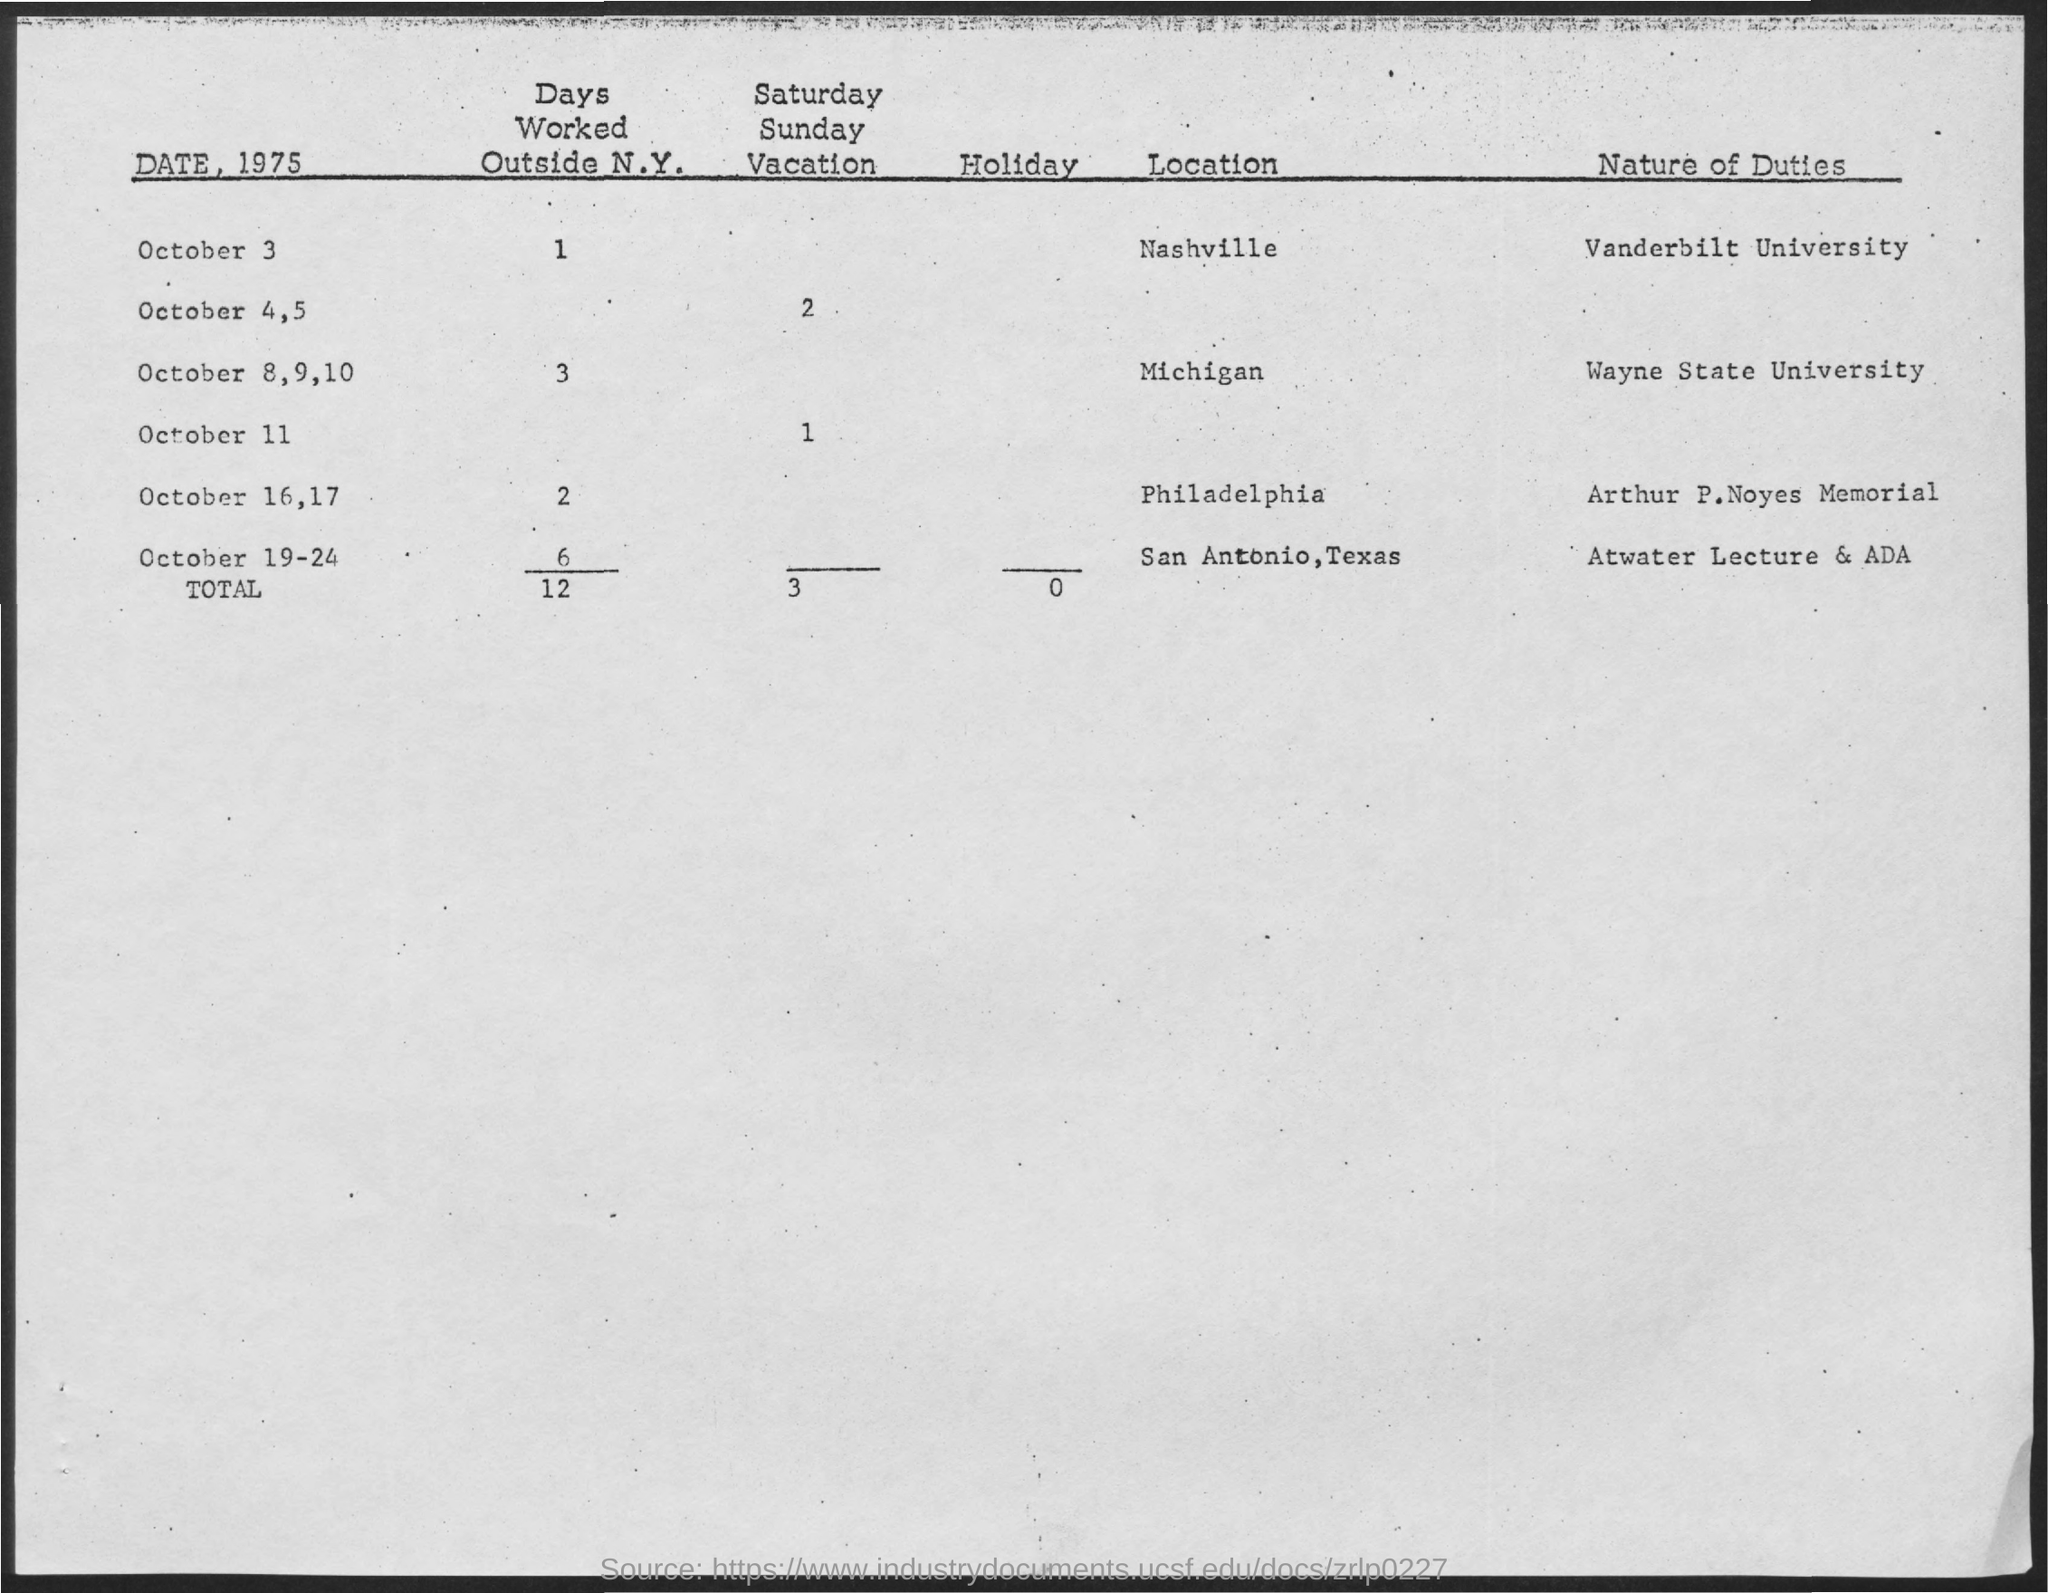List a handful of essential elements in this visual. In total, the individual worked 12 days outside of New York. On October 3, the number of days worked outside of New York is one. What is the nature of duty on October 3, 2023, at Vanderbilt University? On October 3, the location is Nashville. The total number of holidays is 0 or more. 